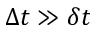Convert formula to latex. <formula><loc_0><loc_0><loc_500><loc_500>\Delta t \gg \delta t</formula> 